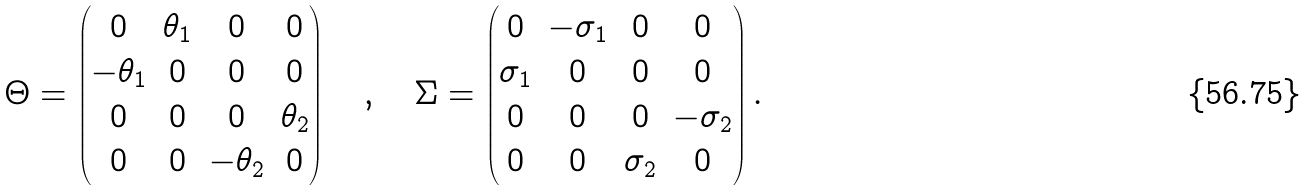Convert formula to latex. <formula><loc_0><loc_0><loc_500><loc_500>\Theta = \left ( \begin{matrix} 0 & \theta _ { 1 } & 0 & 0 \\ - \theta _ { 1 } & 0 & 0 & 0 \\ 0 & 0 & 0 & \theta _ { 2 } \\ 0 & 0 & - \theta _ { 2 } & 0 \end{matrix} \right ) \quad , \quad \Sigma = \left ( \begin{matrix} 0 & - \sigma _ { 1 } & 0 & 0 \\ \sigma _ { 1 } & 0 & 0 & 0 \\ 0 & 0 & 0 & - \sigma _ { 2 } \\ 0 & 0 & \sigma _ { 2 } & 0 \end{matrix} \right ) .</formula> 